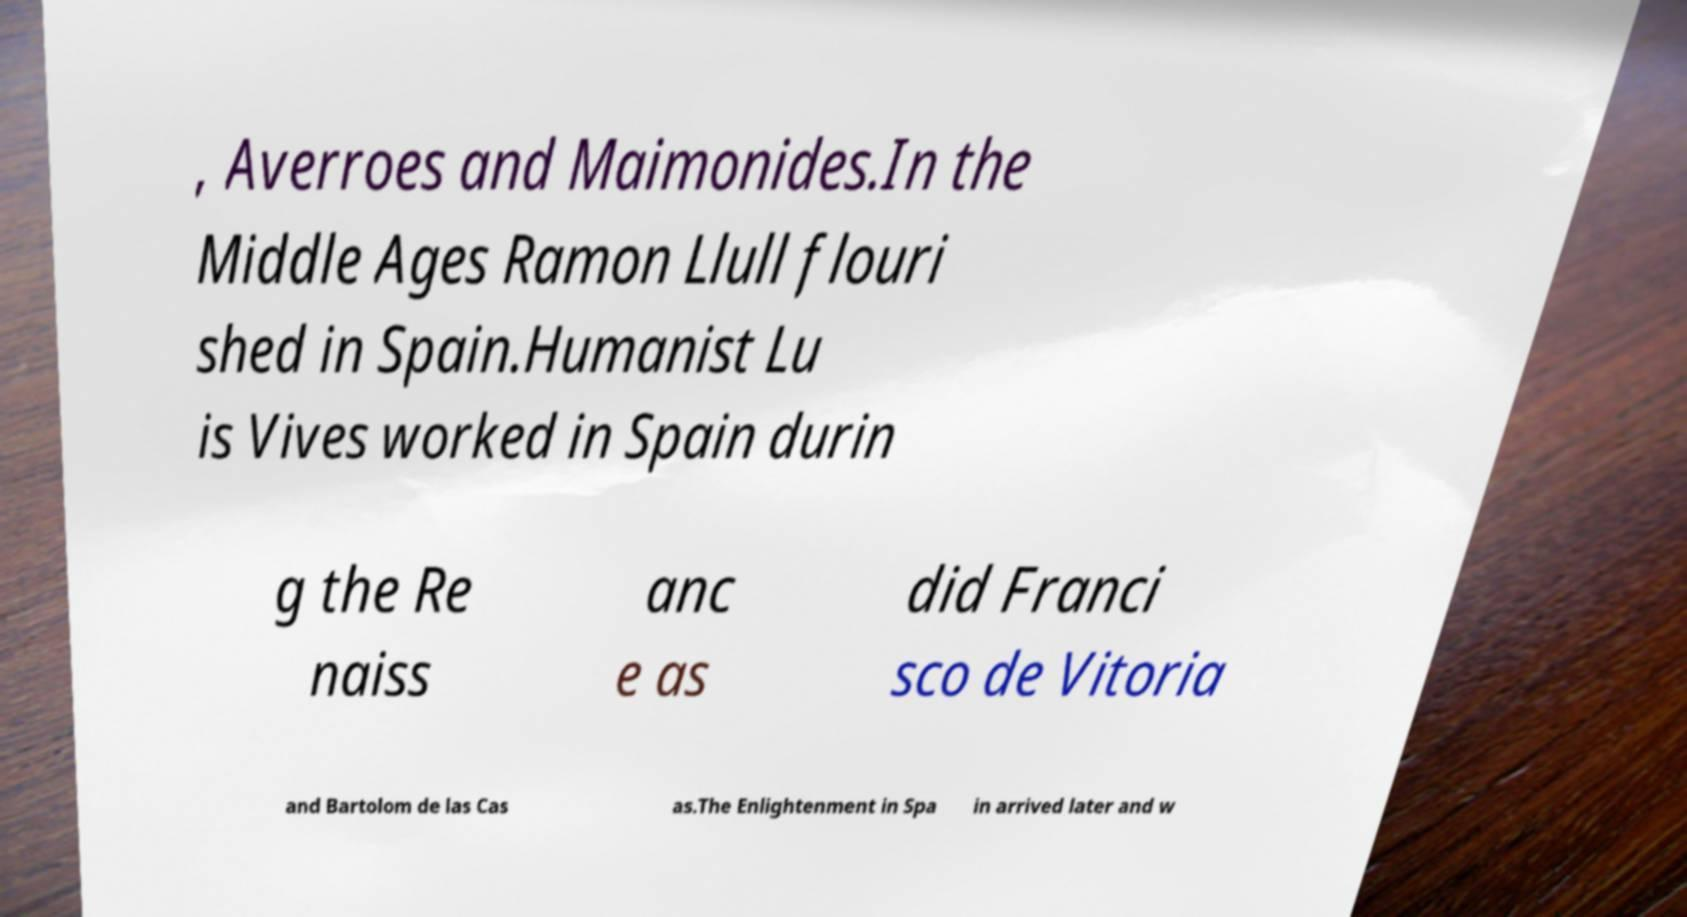There's text embedded in this image that I need extracted. Can you transcribe it verbatim? , Averroes and Maimonides.In the Middle Ages Ramon Llull flouri shed in Spain.Humanist Lu is Vives worked in Spain durin g the Re naiss anc e as did Franci sco de Vitoria and Bartolom de las Cas as.The Enlightenment in Spa in arrived later and w 